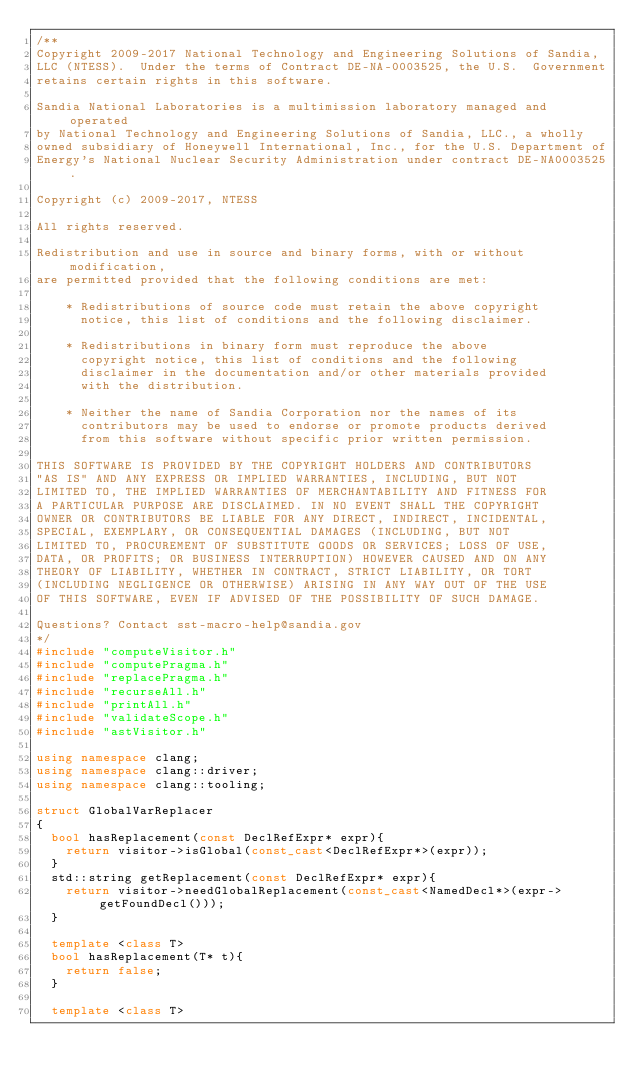<code> <loc_0><loc_0><loc_500><loc_500><_C++_>/**
Copyright 2009-2017 National Technology and Engineering Solutions of Sandia, 
LLC (NTESS).  Under the terms of Contract DE-NA-0003525, the U.S.  Government 
retains certain rights in this software.

Sandia National Laboratories is a multimission laboratory managed and operated
by National Technology and Engineering Solutions of Sandia, LLC., a wholly 
owned subsidiary of Honeywell International, Inc., for the U.S. Department of 
Energy's National Nuclear Security Administration under contract DE-NA0003525.

Copyright (c) 2009-2017, NTESS

All rights reserved.

Redistribution and use in source and binary forms, with or without modification, 
are permitted provided that the following conditions are met:

    * Redistributions of source code must retain the above copyright
      notice, this list of conditions and the following disclaimer.

    * Redistributions in binary form must reproduce the above
      copyright notice, this list of conditions and the following
      disclaimer in the documentation and/or other materials provided
      with the distribution.

    * Neither the name of Sandia Corporation nor the names of its
      contributors may be used to endorse or promote products derived
      from this software without specific prior written permission.

THIS SOFTWARE IS PROVIDED BY THE COPYRIGHT HOLDERS AND CONTRIBUTORS
"AS IS" AND ANY EXPRESS OR IMPLIED WARRANTIES, INCLUDING, BUT NOT
LIMITED TO, THE IMPLIED WARRANTIES OF MERCHANTABILITY AND FITNESS FOR
A PARTICULAR PURPOSE ARE DISCLAIMED. IN NO EVENT SHALL THE COPYRIGHT
OWNER OR CONTRIBUTORS BE LIABLE FOR ANY DIRECT, INDIRECT, INCIDENTAL,
SPECIAL, EXEMPLARY, OR CONSEQUENTIAL DAMAGES (INCLUDING, BUT NOT
LIMITED TO, PROCUREMENT OF SUBSTITUTE GOODS OR SERVICES; LOSS OF USE,
DATA, OR PROFITS; OR BUSINESS INTERRUPTION) HOWEVER CAUSED AND ON ANY
THEORY OF LIABILITY, WHETHER IN CONTRACT, STRICT LIABILITY, OR TORT
(INCLUDING NEGLIGENCE OR OTHERWISE) ARISING IN ANY WAY OUT OF THE USE
OF THIS SOFTWARE, EVEN IF ADVISED OF THE POSSIBILITY OF SUCH DAMAGE.

Questions? Contact sst-macro-help@sandia.gov
*/
#include "computeVisitor.h"
#include "computePragma.h"
#include "replacePragma.h"
#include "recurseAll.h"
#include "printAll.h"
#include "validateScope.h"
#include "astVisitor.h"

using namespace clang;
using namespace clang::driver;
using namespace clang::tooling;

struct GlobalVarReplacer
{
  bool hasReplacement(const DeclRefExpr* expr){
    return visitor->isGlobal(const_cast<DeclRefExpr*>(expr));
  }
  std::string getReplacement(const DeclRefExpr* expr){
    return visitor->needGlobalReplacement(const_cast<NamedDecl*>(expr->getFoundDecl()));
  }

  template <class T>
  bool hasReplacement(T* t){
    return false;
  }

  template <class T></code> 